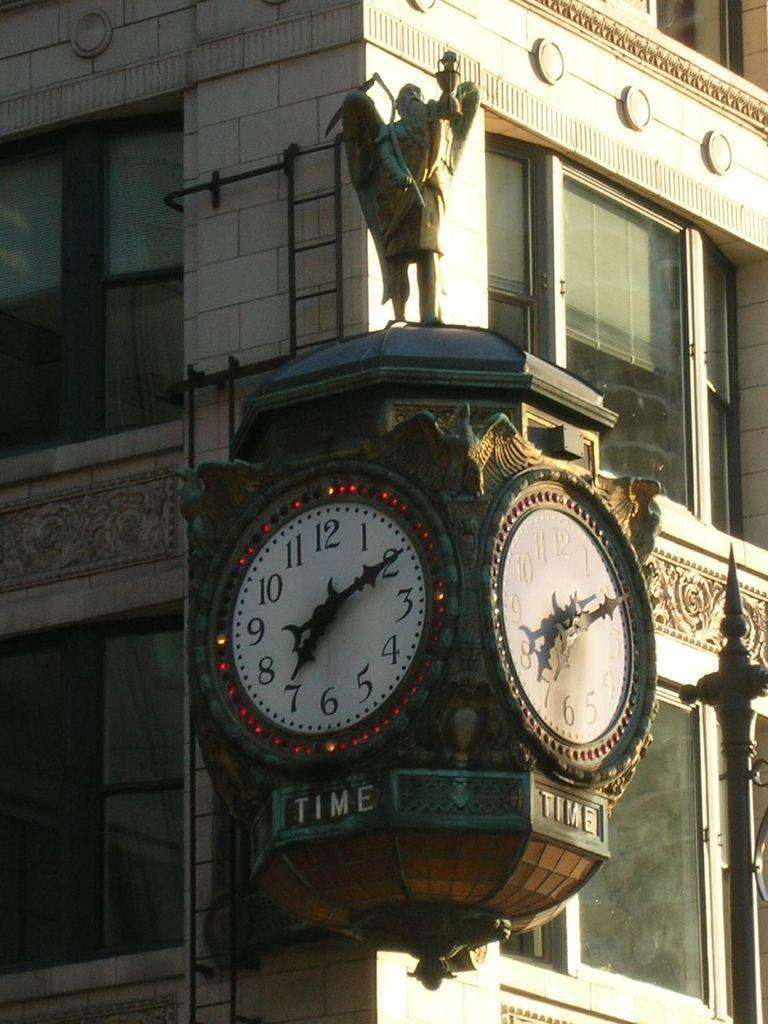<image>
Provide a brief description of the given image. A clock the reads 7:10 has time written below it. 